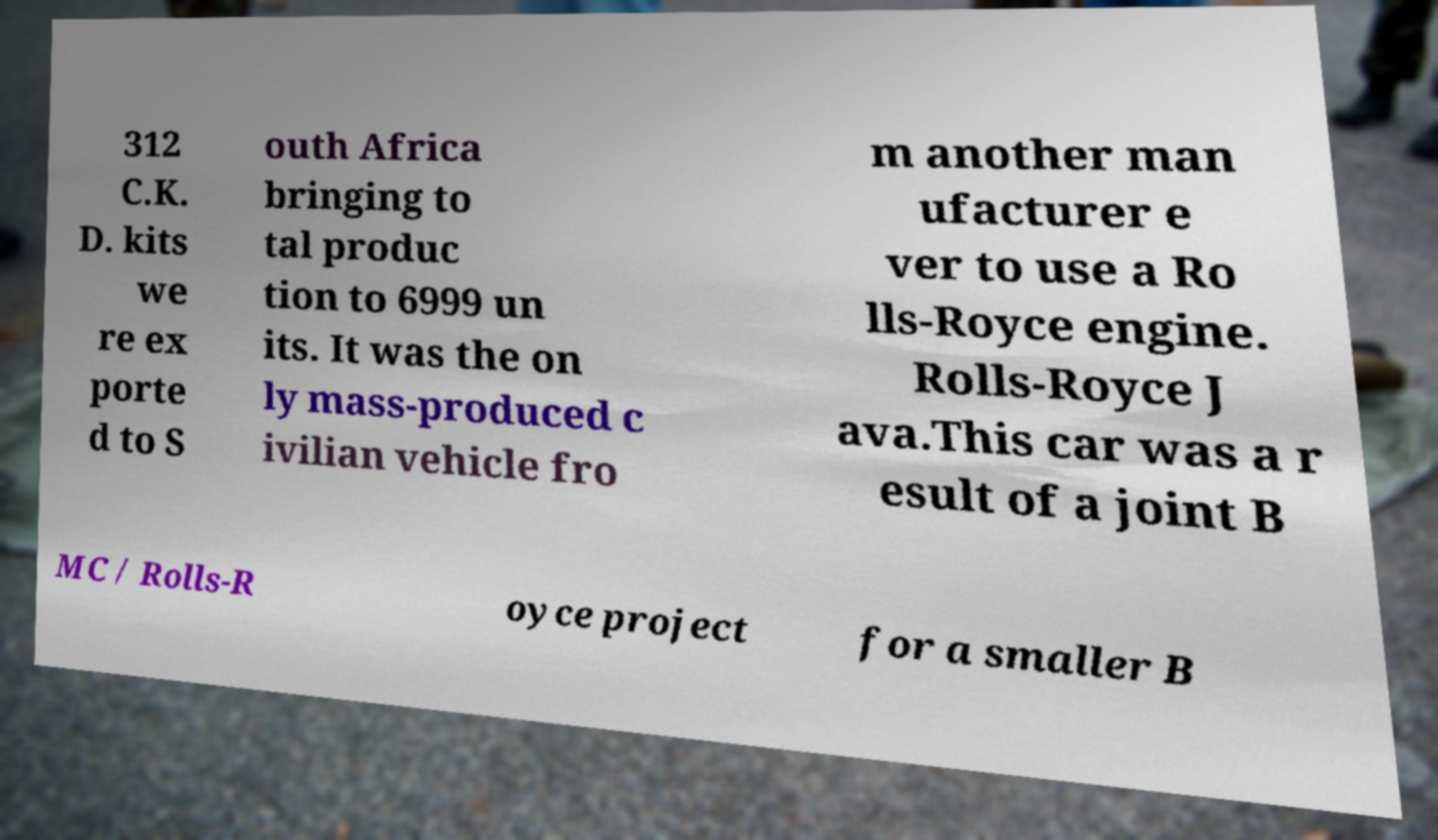There's text embedded in this image that I need extracted. Can you transcribe it verbatim? 312 C.K. D. kits we re ex porte d to S outh Africa bringing to tal produc tion to 6999 un its. It was the on ly mass-produced c ivilian vehicle fro m another man ufacturer e ver to use a Ro lls-Royce engine. Rolls-Royce J ava.This car was a r esult of a joint B MC / Rolls-R oyce project for a smaller B 